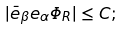Convert formula to latex. <formula><loc_0><loc_0><loc_500><loc_500>| \bar { e } _ { \beta } e _ { \alpha } \Phi _ { R } | \leq C ;</formula> 